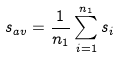<formula> <loc_0><loc_0><loc_500><loc_500>s _ { a v } = \frac { 1 } { n _ { 1 } } \sum _ { i = 1 } ^ { n _ { 1 } } s _ { i }</formula> 